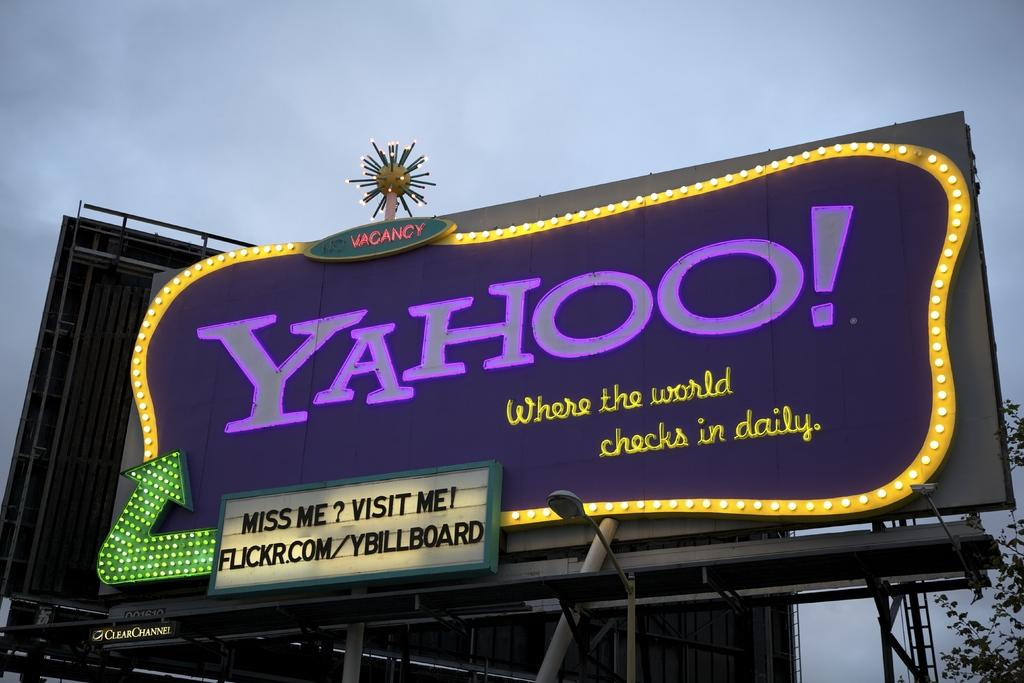<image>
Render a clear and concise summary of the photo. a billboard that says 'yahoo! where the world checks in daily' on it 